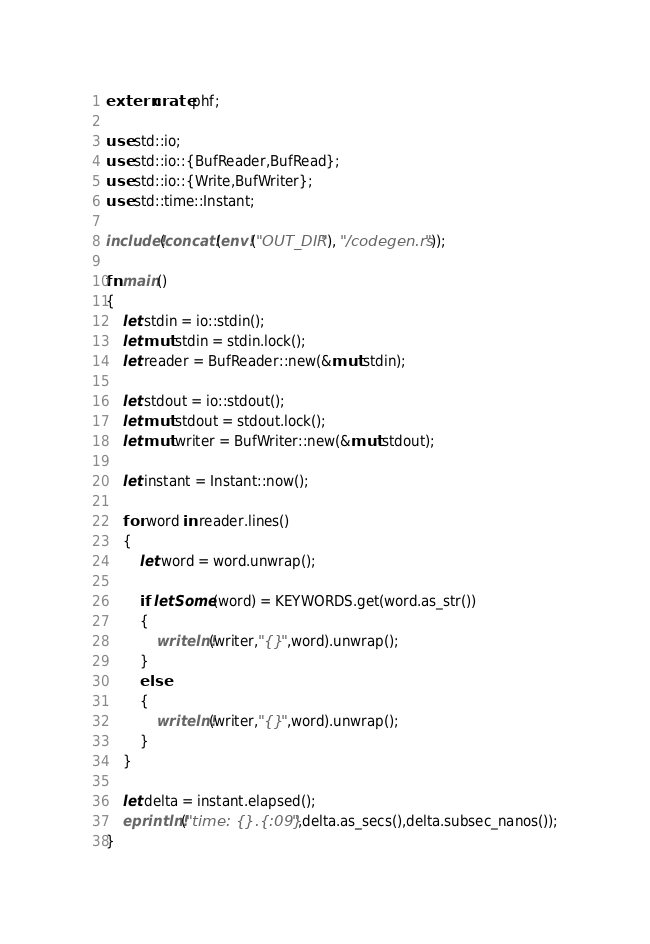Convert code to text. <code><loc_0><loc_0><loc_500><loc_500><_Rust_>extern crate phf;

use std::io;
use std::io::{BufReader,BufRead};
use std::io::{Write,BufWriter};
use std::time::Instant;

include!(concat!(env!("OUT_DIR"), "/codegen.rs"));

fn main()
{
	let stdin = io::stdin();
	let mut stdin = stdin.lock();
	let reader = BufReader::new(&mut stdin);

	let stdout = io::stdout();
	let mut stdout = stdout.lock();
	let mut writer = BufWriter::new(&mut stdout);

	let instant = Instant::now();

	for word in reader.lines()
	{
		let word = word.unwrap();

		if let Some(word) = KEYWORDS.get(word.as_str())
		{
			writeln!(writer,"{}",word).unwrap();
		}
		else
		{
			writeln!(writer,"{}",word).unwrap();
		}
	}

	let delta = instant.elapsed();
	eprintln!("time: {}.{:09}",delta.as_secs(),delta.subsec_nanos());
}

</code> 